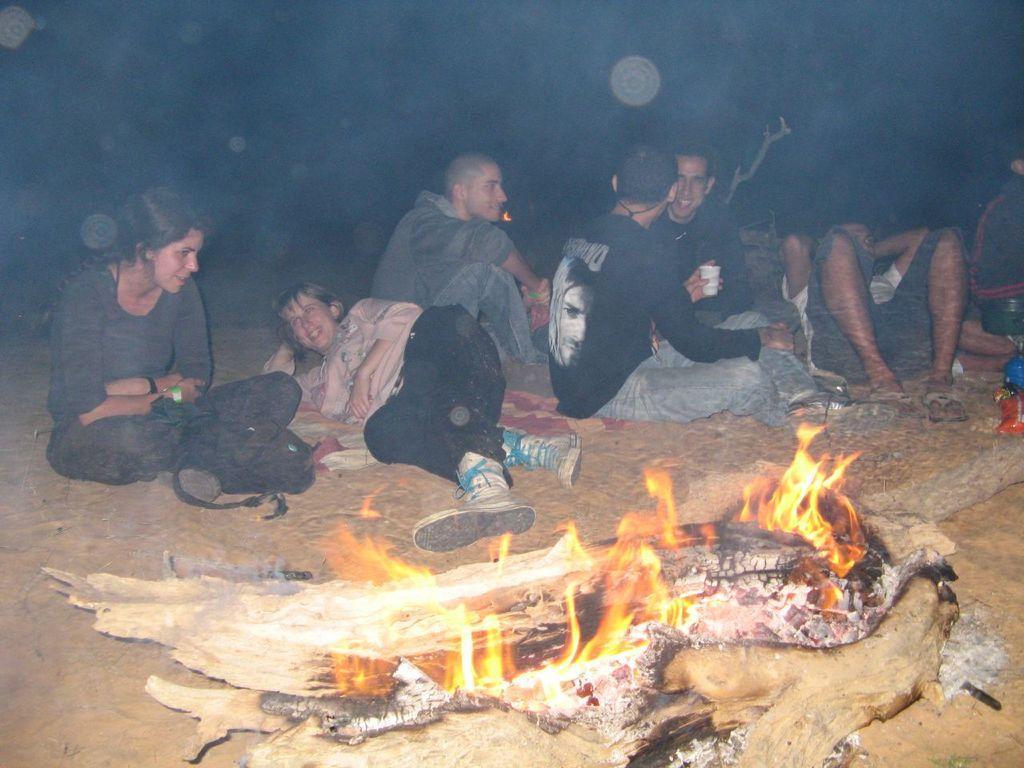Please provide a concise description of this image. In this image there are a few people lying and sitting on the surface, in front of them there are some objects and a burning wooden log. Behind them there is a branch of a tree 